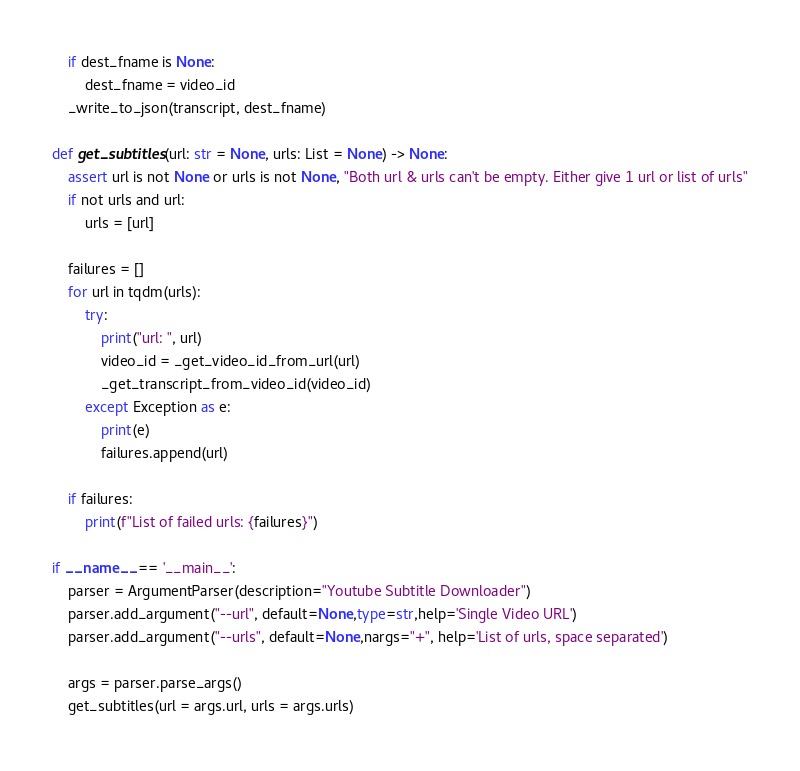Convert code to text. <code><loc_0><loc_0><loc_500><loc_500><_Python_>
    if dest_fname is None: 
        dest_fname = video_id
    _write_to_json(transcript, dest_fname)

def get_subtitles(url: str = None, urls: List = None) -> None:
    assert url is not None or urls is not None, "Both url & urls can't be empty. Either give 1 url or list of urls"
    if not urls and url:
        urls = [url]
    
    failures = []
    for url in tqdm(urls):
        try:
            print("url: ", url)
            video_id = _get_video_id_from_url(url)
            _get_transcript_from_video_id(video_id)
        except Exception as e:
            print(e)
            failures.append(url)
    
    if failures:
        print(f"List of failed urls: {failures}")

if __name__ == '__main__':
    parser = ArgumentParser(description="Youtube Subtitle Downloader")
    parser.add_argument("--url", default=None,type=str,help='Single Video URL')
    parser.add_argument("--urls", default=None,nargs="+", help='List of urls, space separated')

    args = parser.parse_args()
    get_subtitles(url = args.url, urls = args.urls)
</code> 